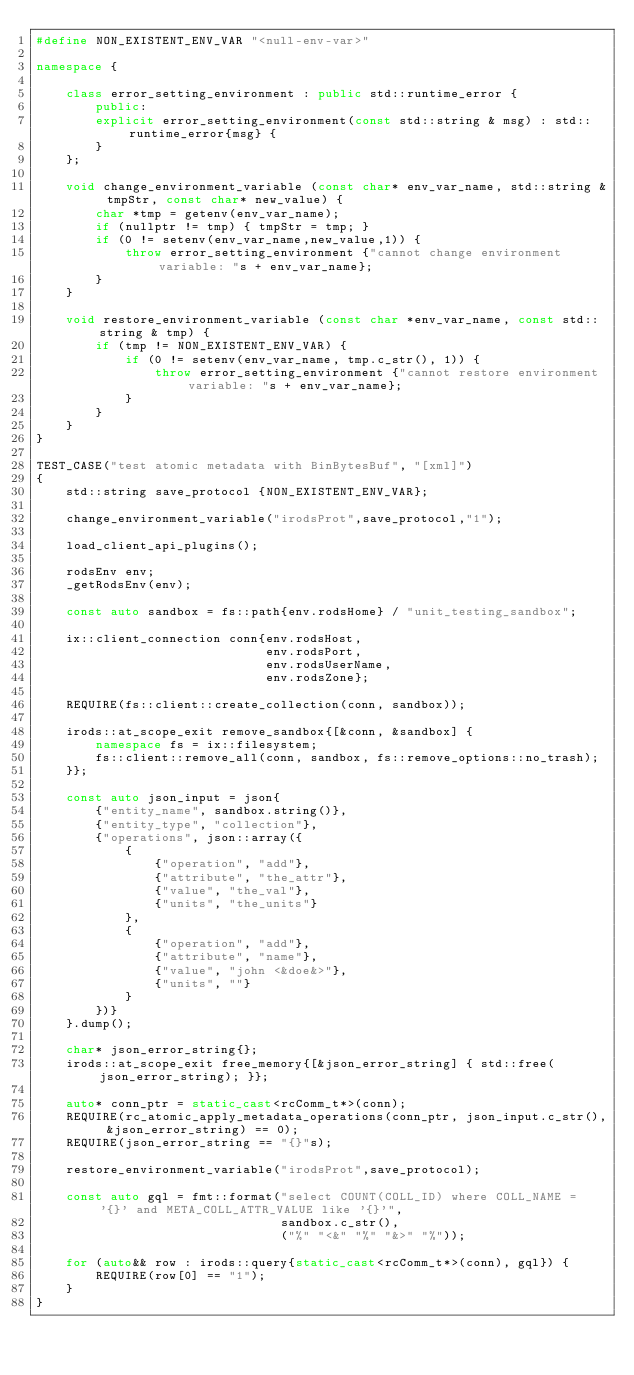<code> <loc_0><loc_0><loc_500><loc_500><_C++_>#define NON_EXISTENT_ENV_VAR "<null-env-var>"

namespace {

    class error_setting_environment : public std::runtime_error {
        public:
        explicit error_setting_environment(const std::string & msg) : std::runtime_error{msg} {
        }
    };

    void change_environment_variable (const char* env_var_name, std::string & tmpStr, const char* new_value) {
        char *tmp = getenv(env_var_name);
        if (nullptr != tmp) { tmpStr = tmp; }
        if (0 != setenv(env_var_name,new_value,1)) {
            throw error_setting_environment {"cannot change environment variable: "s + env_var_name};
        }
    }

    void restore_environment_variable (const char *env_var_name, const std::string & tmp) {
        if (tmp != NON_EXISTENT_ENV_VAR) {
            if (0 != setenv(env_var_name, tmp.c_str(), 1)) {
                throw error_setting_environment {"cannot restore environment variable: "s + env_var_name};
            }
        }
    }
}

TEST_CASE("test atomic metadata with BinBytesBuf", "[xml]")
{
    std::string save_protocol {NON_EXISTENT_ENV_VAR};

    change_environment_variable("irodsProt",save_protocol,"1");

    load_client_api_plugins();

    rodsEnv env;
    _getRodsEnv(env);

    const auto sandbox = fs::path{env.rodsHome} / "unit_testing_sandbox";

    ix::client_connection conn{env.rodsHost,
                               env.rodsPort,
                               env.rodsUserName,
                               env.rodsZone};

    REQUIRE(fs::client::create_collection(conn, sandbox));

    irods::at_scope_exit remove_sandbox{[&conn, &sandbox] {
        namespace fs = ix::filesystem;
        fs::client::remove_all(conn, sandbox, fs::remove_options::no_trash);
    }};

    const auto json_input = json{
        {"entity_name", sandbox.string()},
        {"entity_type", "collection"},
        {"operations", json::array({
            {
                {"operation", "add"},
                {"attribute", "the_attr"},
                {"value", "the_val"},
                {"units", "the_units"}
            },
            {
                {"operation", "add"},
                {"attribute", "name"},
                {"value", "john <&doe&>"},
                {"units", ""}
            }
        })}
    }.dump();

    char* json_error_string{};
    irods::at_scope_exit free_memory{[&json_error_string] { std::free(json_error_string); }};

    auto* conn_ptr = static_cast<rcComm_t*>(conn);
    REQUIRE(rc_atomic_apply_metadata_operations(conn_ptr, json_input.c_str(), &json_error_string) == 0);
    REQUIRE(json_error_string == "{}"s);

    restore_environment_variable("irodsProt",save_protocol);

    const auto gql = fmt::format("select COUNT(COLL_ID) where COLL_NAME = '{}' and META_COLL_ATTR_VALUE like '{}'",
                                 sandbox.c_str(), 
                                 ("%" "<&" "%" "&>" "%"));

    for (auto&& row : irods::query{static_cast<rcComm_t*>(conn), gql}) {
        REQUIRE(row[0] == "1");
    }
}
</code> 